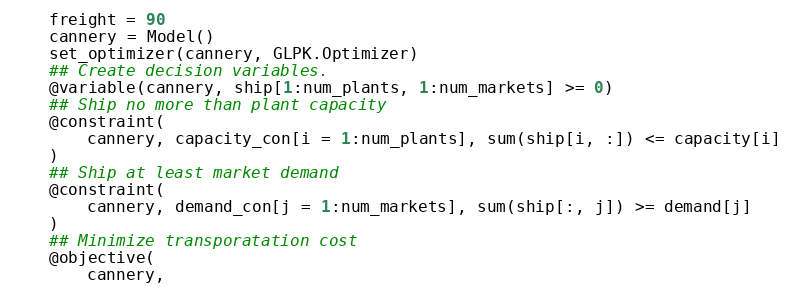Convert code to text. <code><loc_0><loc_0><loc_500><loc_500><_Julia_>    freight = 90
    cannery = Model()
    set_optimizer(cannery, GLPK.Optimizer)
    ## Create decision variables.
    @variable(cannery, ship[1:num_plants, 1:num_markets] >= 0)
    ## Ship no more than plant capacity
    @constraint(
        cannery, capacity_con[i = 1:num_plants], sum(ship[i, :]) <= capacity[i]
    )
    ## Ship at least market demand
    @constraint(
        cannery, demand_con[j = 1:num_markets], sum(ship[:, j]) >= demand[j]
    )
    ## Minimize transporatation cost
    @objective(
        cannery,</code> 